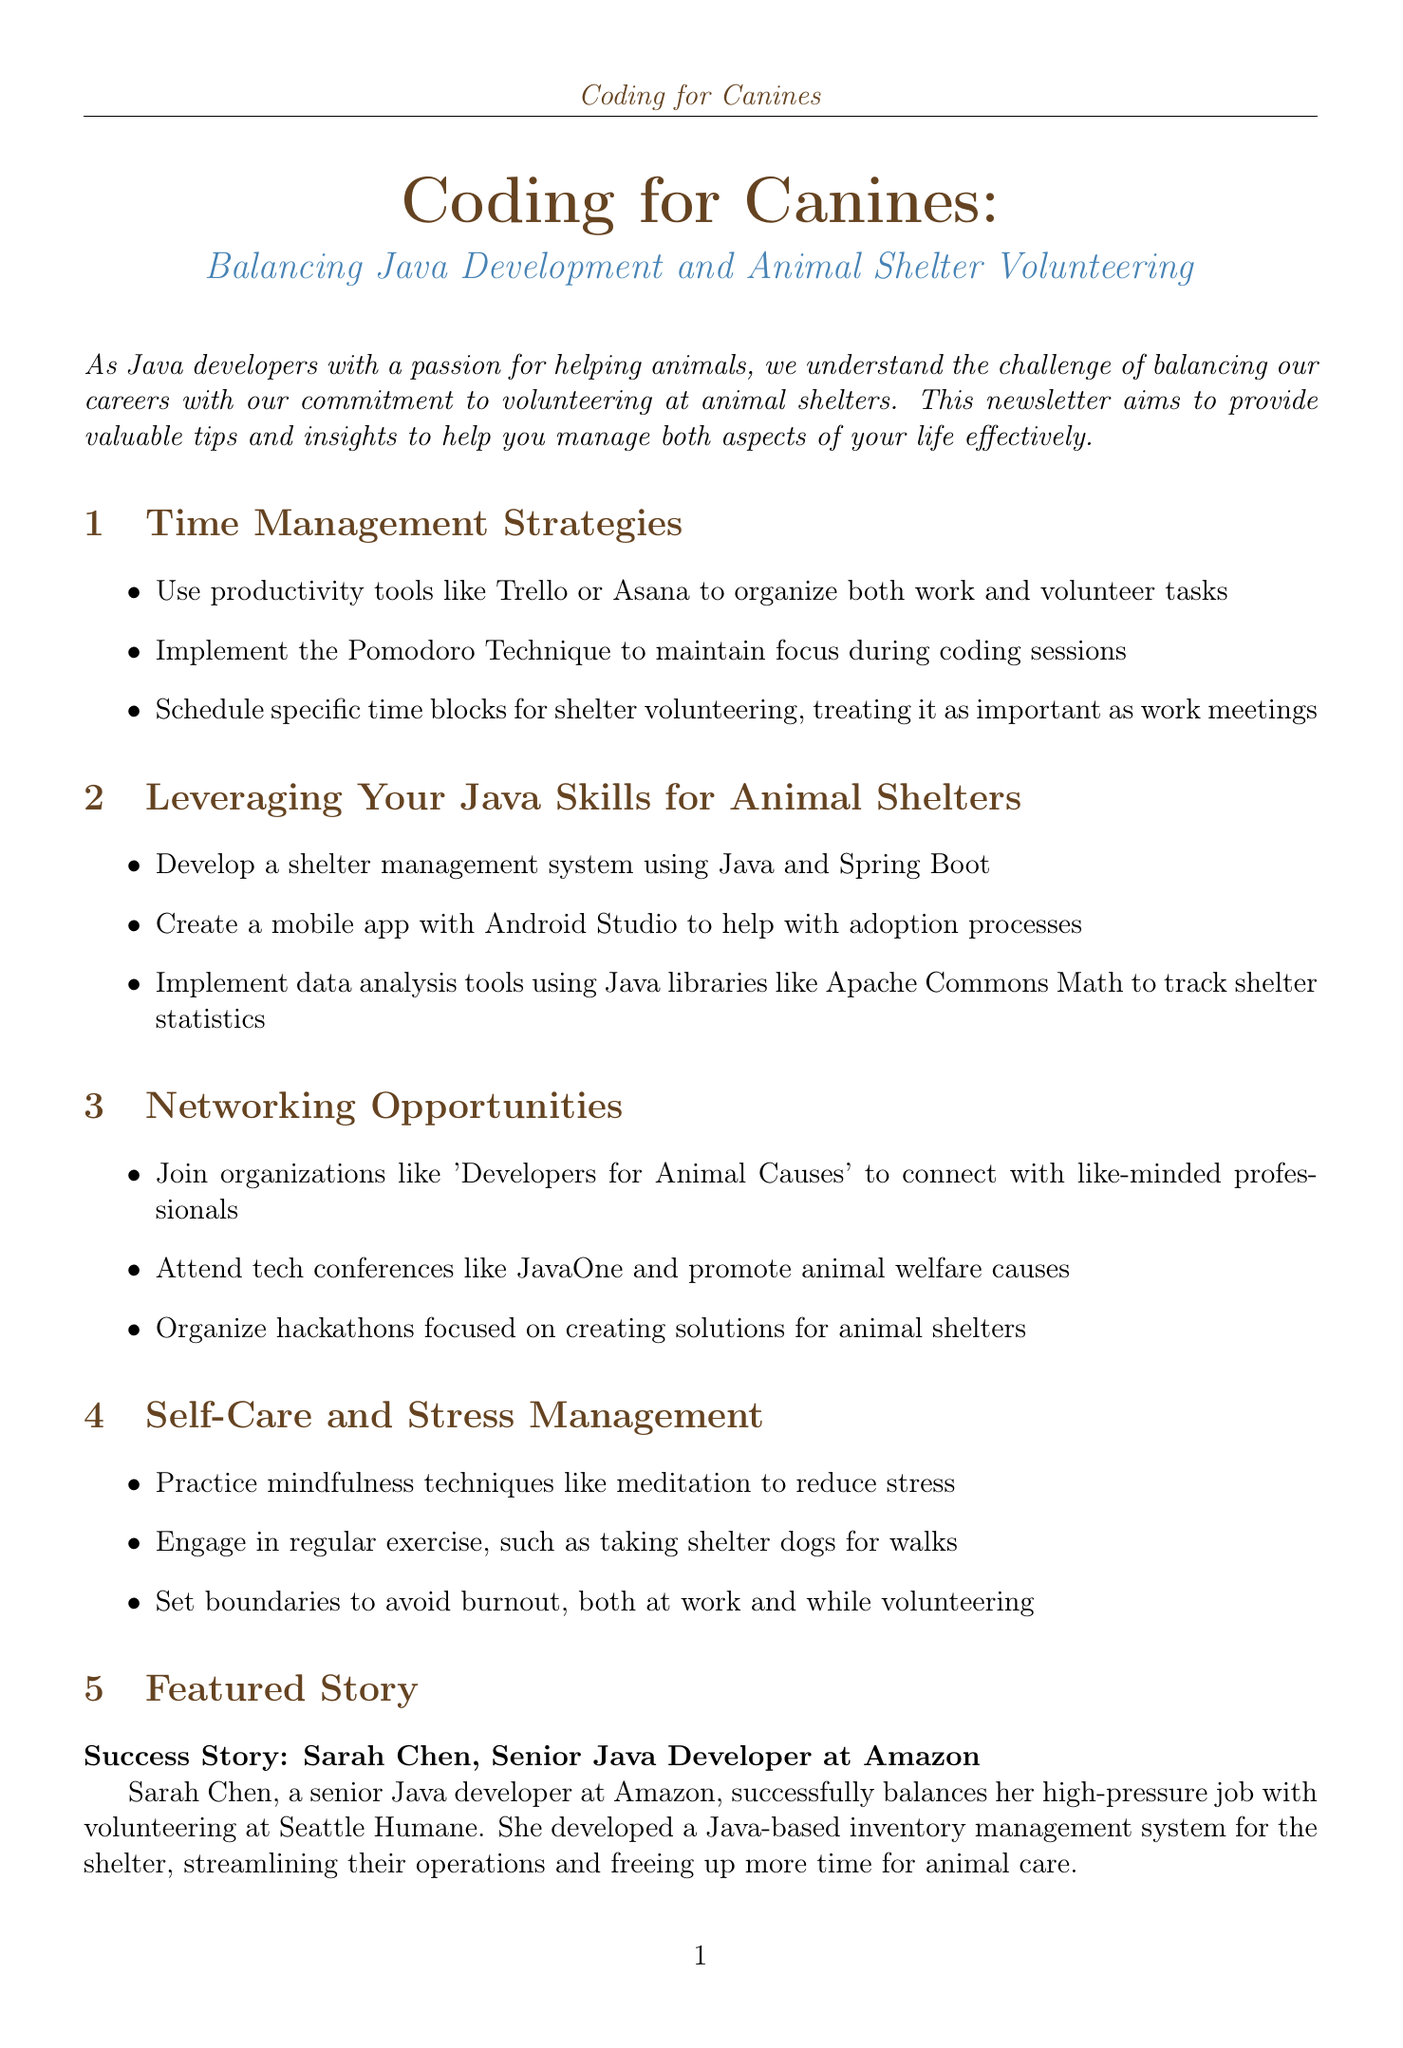What is the title of the newsletter? The title of the newsletter is "Coding for Canines: Balancing Java Development and Animal Shelter Volunteering."
Answer: Coding for Canines: Balancing Java Development and Animal Shelter Volunteering Who is featured in the success story? The success story features Sarah Chen, a senior Java developer at Amazon.
Answer: Sarah Chen What is one tool recommended for time management? The document suggests using productivity tools such as Trello or Asana for organizing tasks.
Answer: Trello or Asana What is the name of the organization to join for networking? The newsletter mentions joining "Developers for Animal Causes" for networking opportunities.
Answer: Developers for Animal Causes How many recommended books are listed? There are three recommended books listed in the resources section.
Answer: Three What technique is suggested for maintaining focus during coding sessions? The Pomodoro Technique is mentioned as a way to maintain focus.
Answer: Pomodoro Technique What is one way to manage stress according to the newsletter? Practicing mindfulness techniques like meditation is suggested for stress management.
Answer: Meditation What should you treat volunteering time as? The newsletter advises treating volunteering time as important as work meetings.
Answer: Important as work meetings 